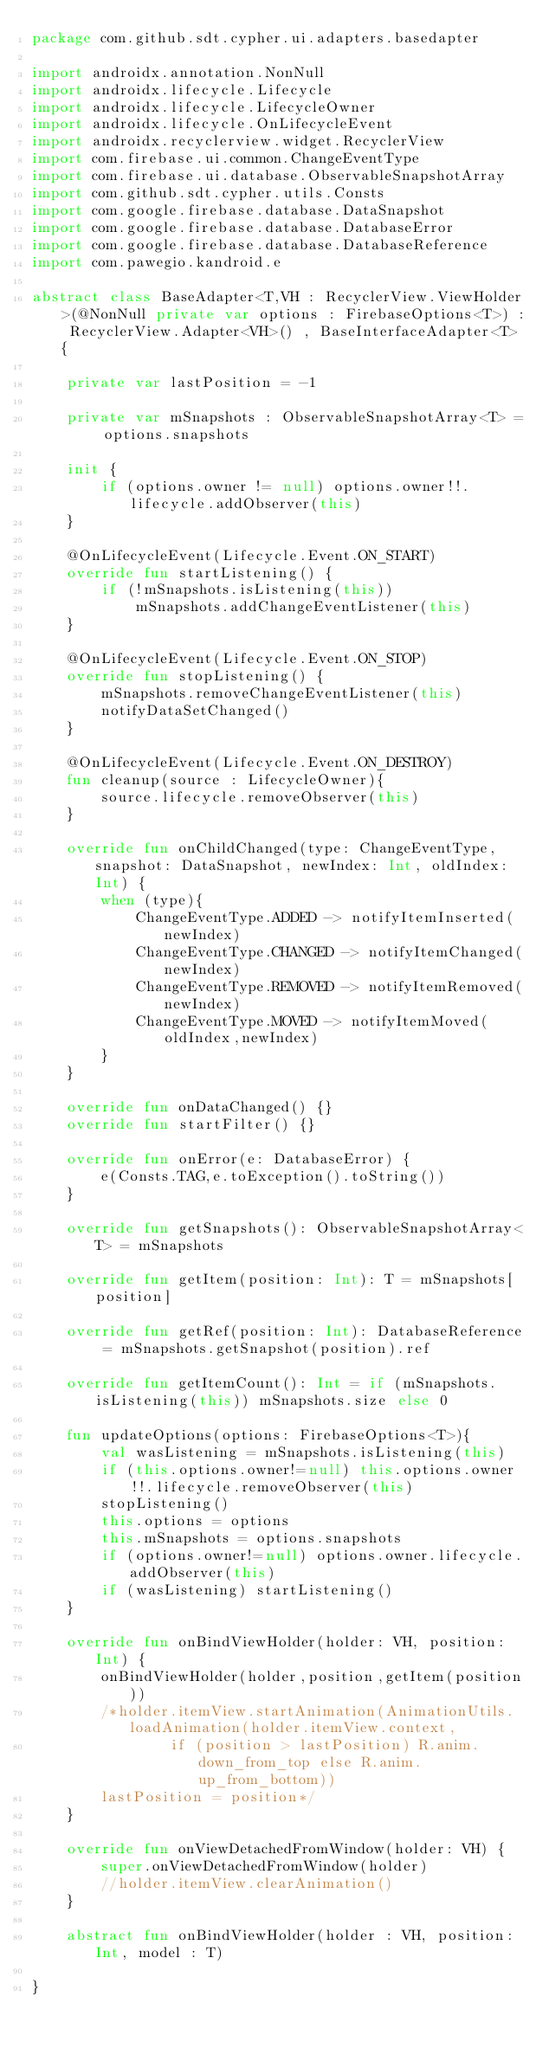Convert code to text. <code><loc_0><loc_0><loc_500><loc_500><_Kotlin_>package com.github.sdt.cypher.ui.adapters.basedapter

import androidx.annotation.NonNull
import androidx.lifecycle.Lifecycle
import androidx.lifecycle.LifecycleOwner
import androidx.lifecycle.OnLifecycleEvent
import androidx.recyclerview.widget.RecyclerView
import com.firebase.ui.common.ChangeEventType
import com.firebase.ui.database.ObservableSnapshotArray
import com.github.sdt.cypher.utils.Consts
import com.google.firebase.database.DataSnapshot
import com.google.firebase.database.DatabaseError
import com.google.firebase.database.DatabaseReference
import com.pawegio.kandroid.e

abstract class BaseAdapter<T,VH : RecyclerView.ViewHolder>(@NonNull private var options : FirebaseOptions<T>) : RecyclerView.Adapter<VH>() , BaseInterfaceAdapter<T> {

    private var lastPosition = -1

    private var mSnapshots : ObservableSnapshotArray<T> = options.snapshots

    init {
        if (options.owner != null) options.owner!!.lifecycle.addObserver(this)
    }

    @OnLifecycleEvent(Lifecycle.Event.ON_START)
    override fun startListening() {
        if (!mSnapshots.isListening(this))
            mSnapshots.addChangeEventListener(this)
    }

    @OnLifecycleEvent(Lifecycle.Event.ON_STOP)
    override fun stopListening() {
        mSnapshots.removeChangeEventListener(this)
        notifyDataSetChanged()
    }

    @OnLifecycleEvent(Lifecycle.Event.ON_DESTROY)
    fun cleanup(source : LifecycleOwner){
        source.lifecycle.removeObserver(this)
    }

    override fun onChildChanged(type: ChangeEventType, snapshot: DataSnapshot, newIndex: Int, oldIndex: Int) {
        when (type){
            ChangeEventType.ADDED -> notifyItemInserted(newIndex)
            ChangeEventType.CHANGED -> notifyItemChanged(newIndex)
            ChangeEventType.REMOVED -> notifyItemRemoved(newIndex)
            ChangeEventType.MOVED -> notifyItemMoved(oldIndex,newIndex)
        }
    }

    override fun onDataChanged() {}
    override fun startFilter() {}

    override fun onError(e: DatabaseError) {
        e(Consts.TAG,e.toException().toString())
    }

    override fun getSnapshots(): ObservableSnapshotArray<T> = mSnapshots

    override fun getItem(position: Int): T = mSnapshots[position]

    override fun getRef(position: Int): DatabaseReference = mSnapshots.getSnapshot(position).ref

    override fun getItemCount(): Int = if (mSnapshots.isListening(this)) mSnapshots.size else 0

    fun updateOptions(options: FirebaseOptions<T>){
        val wasListening = mSnapshots.isListening(this)
        if (this.options.owner!=null) this.options.owner!!.lifecycle.removeObserver(this)
        stopListening()
        this.options = options
        this.mSnapshots = options.snapshots
        if (options.owner!=null) options.owner.lifecycle.addObserver(this)
        if (wasListening) startListening()
    }

    override fun onBindViewHolder(holder: VH, position: Int) {
        onBindViewHolder(holder,position,getItem(position))
        /*holder.itemView.startAnimation(AnimationUtils.loadAnimation(holder.itemView.context,
                if (position > lastPosition) R.anim.down_from_top else R.anim.up_from_bottom))
        lastPosition = position*/
    }

    override fun onViewDetachedFromWindow(holder: VH) {
        super.onViewDetachedFromWindow(holder)
        //holder.itemView.clearAnimation()
    }

    abstract fun onBindViewHolder(holder : VH, position: Int, model : T)

}</code> 